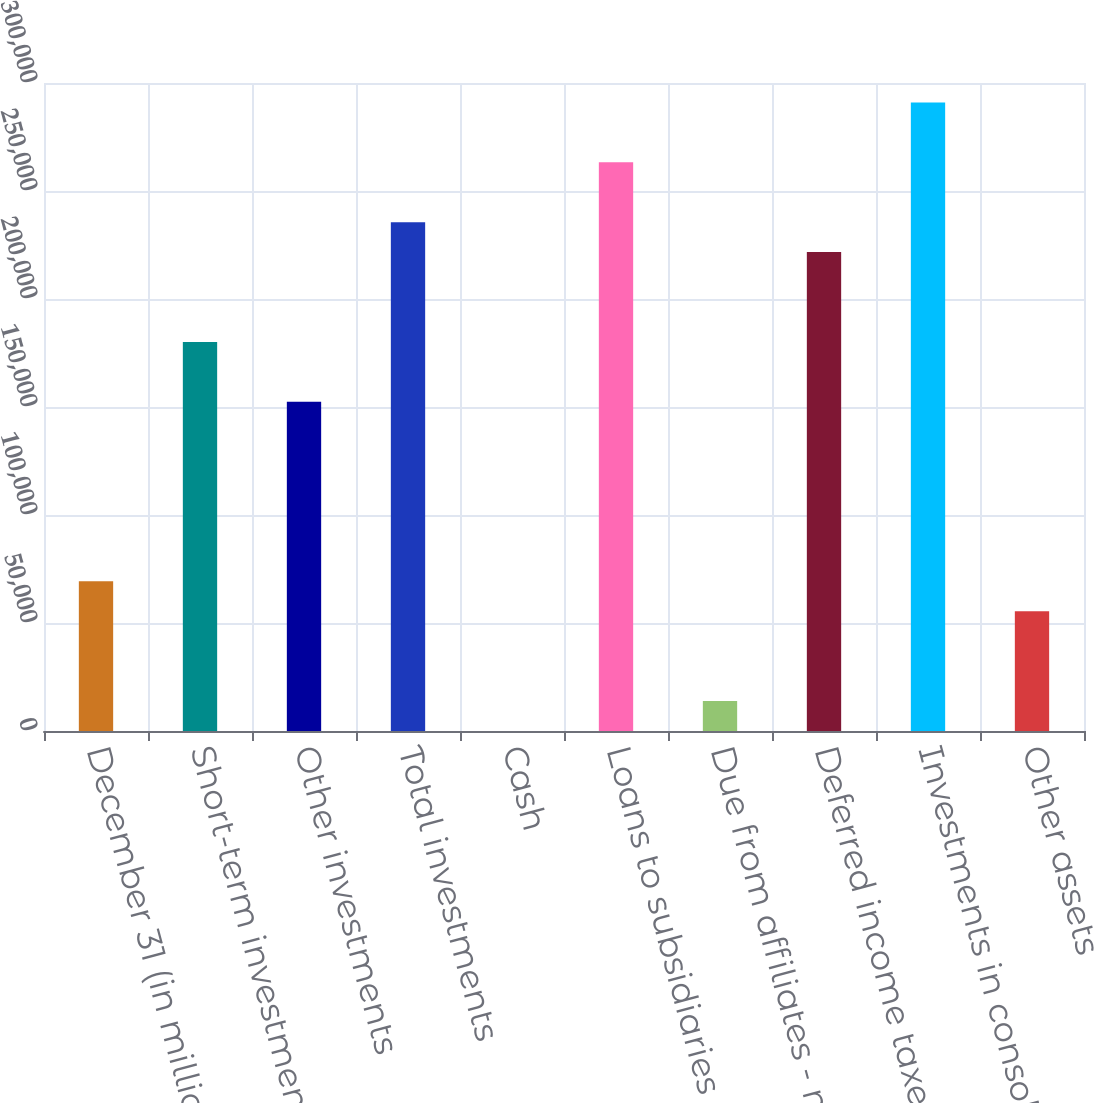Convert chart to OTSL. <chart><loc_0><loc_0><loc_500><loc_500><bar_chart><fcel>December 31 (in millions)<fcel>Short-term investments<fcel>Other investments<fcel>Total investments<fcel>Cash<fcel>Loans to subsidiaries<fcel>Due from affiliates - net<fcel>Deferred income taxes<fcel>Investments in consolidated<fcel>Other assets<nl><fcel>69306.5<fcel>180149<fcel>152438<fcel>235570<fcel>30<fcel>263281<fcel>13885.3<fcel>221715<fcel>290991<fcel>55451.2<nl></chart> 